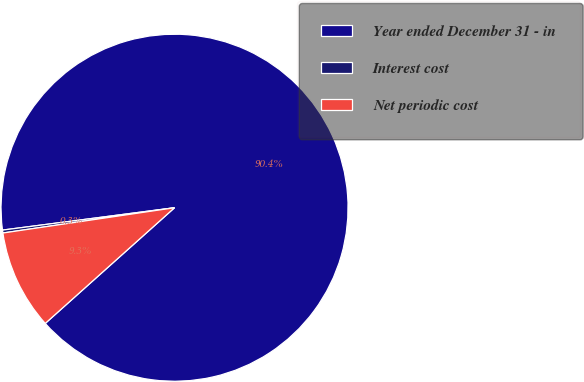Convert chart. <chart><loc_0><loc_0><loc_500><loc_500><pie_chart><fcel>Year ended December 31 - in<fcel>Interest cost<fcel>Net periodic cost<nl><fcel>90.44%<fcel>0.27%<fcel>9.29%<nl></chart> 